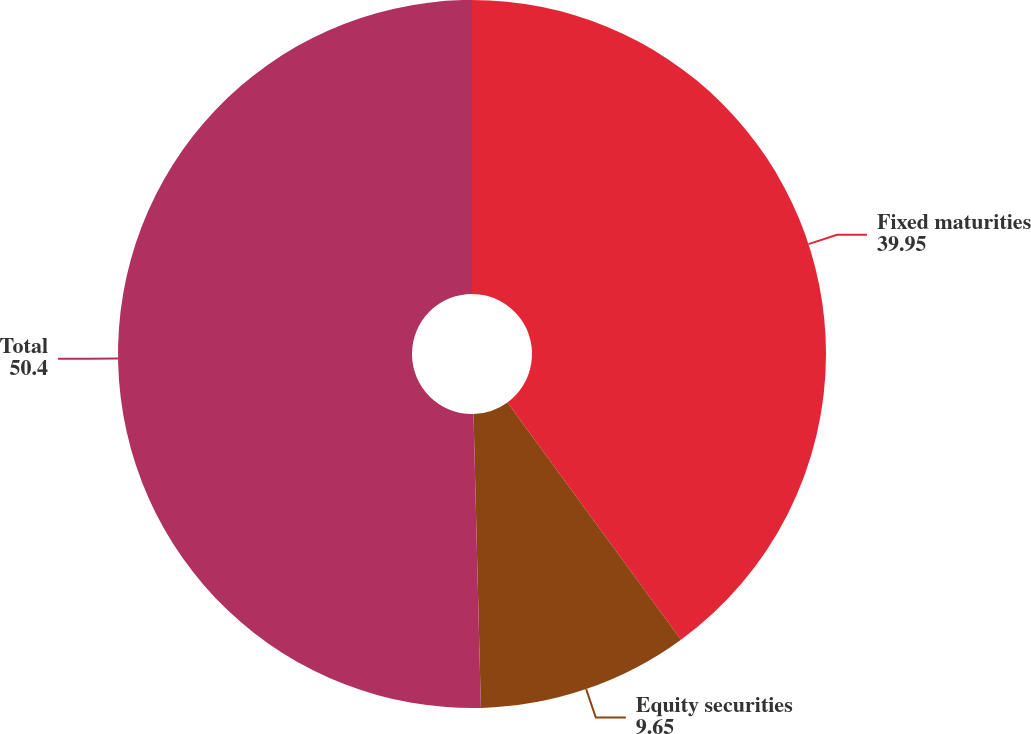Convert chart to OTSL. <chart><loc_0><loc_0><loc_500><loc_500><pie_chart><fcel>Fixed maturities<fcel>Equity securities<fcel>Total<nl><fcel>39.95%<fcel>9.65%<fcel>50.4%<nl></chart> 